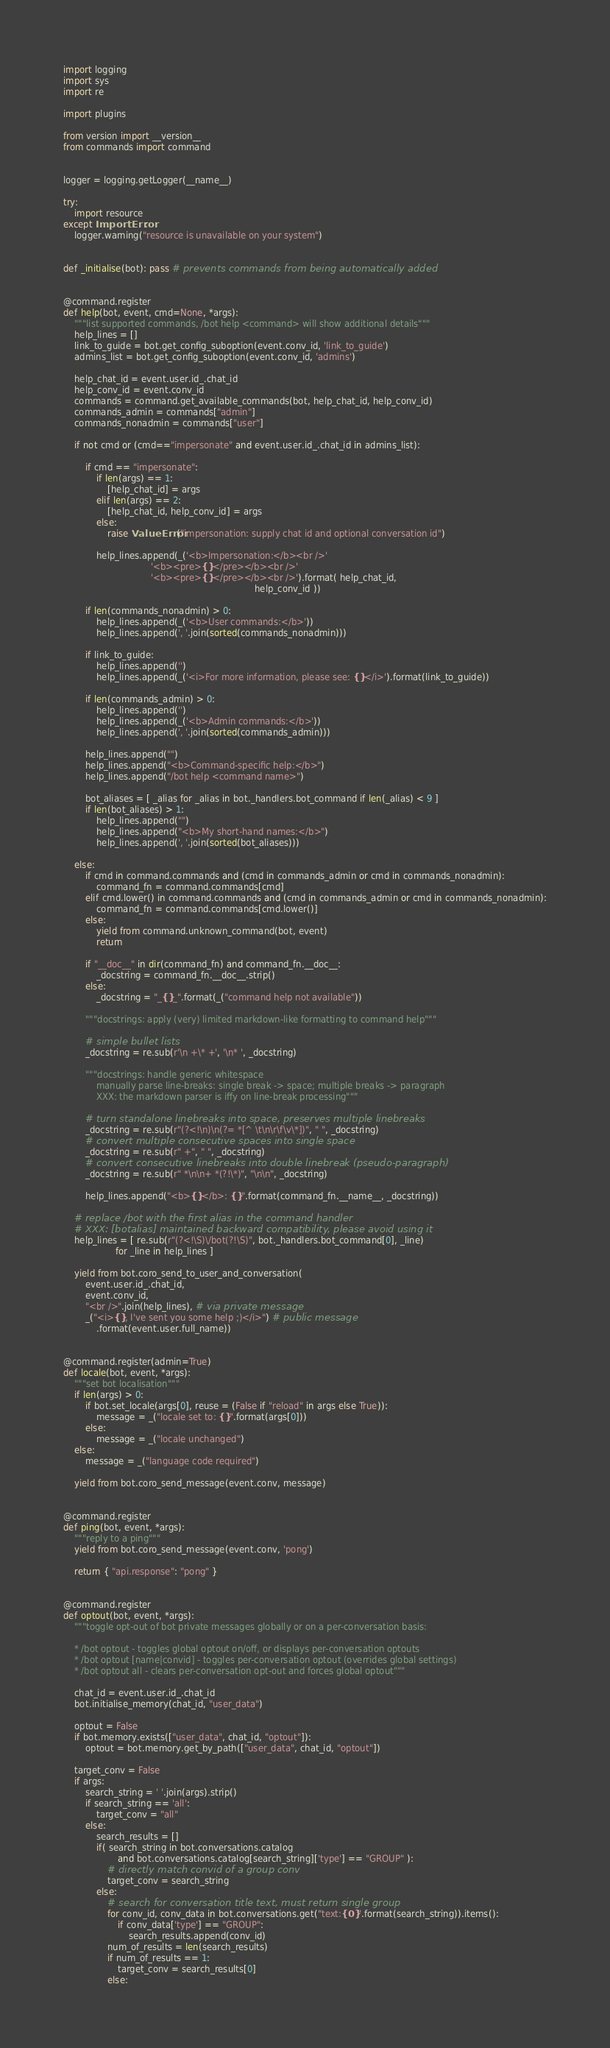Convert code to text. <code><loc_0><loc_0><loc_500><loc_500><_Python_>import logging
import sys
import re

import plugins

from version import __version__
from commands import command


logger = logging.getLogger(__name__)

try:
    import resource
except ImportError:
    logger.warning("resource is unavailable on your system")


def _initialise(bot): pass # prevents commands from being automatically added


@command.register
def help(bot, event, cmd=None, *args):
    """list supported commands, /bot help <command> will show additional details"""
    help_lines = []
    link_to_guide = bot.get_config_suboption(event.conv_id, 'link_to_guide')
    admins_list = bot.get_config_suboption(event.conv_id, 'admins')

    help_chat_id = event.user.id_.chat_id
    help_conv_id = event.conv_id
    commands = command.get_available_commands(bot, help_chat_id, help_conv_id)
    commands_admin = commands["admin"]
    commands_nonadmin = commands["user"]

    if not cmd or (cmd=="impersonate" and event.user.id_.chat_id in admins_list):

        if cmd == "impersonate":
            if len(args) == 1:
                [help_chat_id] = args
            elif len(args) == 2:
                [help_chat_id, help_conv_id] = args
            else:
                raise ValueError("impersonation: supply chat id and optional conversation id")

            help_lines.append(_('<b>Impersonation:</b><br />'
                                '<b><pre>{}</pre></b><br />'
                                '<b><pre>{}</pre></b><br />').format( help_chat_id,
                                                                      help_conv_id ))

        if len(commands_nonadmin) > 0:
            help_lines.append(_('<b>User commands:</b>'))
            help_lines.append(', '.join(sorted(commands_nonadmin)))

        if link_to_guide:
            help_lines.append('')
            help_lines.append(_('<i>For more information, please see: {}</i>').format(link_to_guide))

        if len(commands_admin) > 0:
            help_lines.append('')
            help_lines.append(_('<b>Admin commands:</b>'))
            help_lines.append(', '.join(sorted(commands_admin)))

        help_lines.append("")
        help_lines.append("<b>Command-specific help:</b>")
        help_lines.append("/bot help <command name>")

        bot_aliases = [ _alias for _alias in bot._handlers.bot_command if len(_alias) < 9 ]
        if len(bot_aliases) > 1:
            help_lines.append("")
            help_lines.append("<b>My short-hand names:</b>")
            help_lines.append(', '.join(sorted(bot_aliases)))

    else:
        if cmd in command.commands and (cmd in commands_admin or cmd in commands_nonadmin):
            command_fn = command.commands[cmd]
        elif cmd.lower() in command.commands and (cmd in commands_admin or cmd in commands_nonadmin):
            command_fn = command.commands[cmd.lower()]
        else:
            yield from command.unknown_command(bot, event)
            return

        if "__doc__" in dir(command_fn) and command_fn.__doc__:
            _docstring = command_fn.__doc__.strip()
        else:
            _docstring = "_{}_".format(_("command help not available"))

        """docstrings: apply (very) limited markdown-like formatting to command help"""

        # simple bullet lists
        _docstring = re.sub(r'\n +\* +', '\n* ', _docstring)

        """docstrings: handle generic whitespace
            manually parse line-breaks: single break -> space; multiple breaks -> paragraph
            XXX: the markdown parser is iffy on line-break processing"""

        # turn standalone linebreaks into space, preserves multiple linebreaks
        _docstring = re.sub(r"(?<!\n)\n(?= *[^ \t\n\r\f\v\*])", " ", _docstring)
        # convert multiple consecutive spaces into single space
        _docstring = re.sub(r" +", " ", _docstring)
        # convert consecutive linebreaks into double linebreak (pseudo-paragraph)
        _docstring = re.sub(r" *\n\n+ *(?!\*)", "\n\n", _docstring)

        help_lines.append("<b>{}</b>: {}".format(command_fn.__name__, _docstring))

    # replace /bot with the first alias in the command handler
    # XXX: [botalias] maintained backward compatibility, please avoid using it
    help_lines = [ re.sub(r"(?<!\S)\/bot(?!\S)", bot._handlers.bot_command[0], _line)
                   for _line in help_lines ]

    yield from bot.coro_send_to_user_and_conversation(
        event.user.id_.chat_id,
        event.conv_id,
        "<br />".join(help_lines), # via private message
        _("<i>{}, I've sent you some help ;)</i>") # public message
            .format(event.user.full_name))


@command.register(admin=True)
def locale(bot, event, *args):
    """set bot localisation"""
    if len(args) > 0:
        if bot.set_locale(args[0], reuse = (False if "reload" in args else True)):
            message = _("locale set to: {}".format(args[0]))
        else:
            message = _("locale unchanged")
    else:
        message = _("language code required")

    yield from bot.coro_send_message(event.conv, message)


@command.register
def ping(bot, event, *args):
    """reply to a ping"""
    yield from bot.coro_send_message(event.conv, 'pong')

    return { "api.response": "pong" }


@command.register
def optout(bot, event, *args):
    """toggle opt-out of bot private messages globally or on a per-conversation basis:

    * /bot optout - toggles global optout on/off, or displays per-conversation optouts
    * /bot optout [name|convid] - toggles per-conversation optout (overrides global settings)
    * /bot optout all - clears per-conversation opt-out and forces global optout"""

    chat_id = event.user.id_.chat_id
    bot.initialise_memory(chat_id, "user_data")

    optout = False
    if bot.memory.exists(["user_data", chat_id, "optout"]):
        optout = bot.memory.get_by_path(["user_data", chat_id, "optout"])

    target_conv = False
    if args:
        search_string = ' '.join(args).strip()
        if search_string == 'all':
            target_conv = "all"
        else:
            search_results = []
            if( search_string in bot.conversations.catalog
                    and bot.conversations.catalog[search_string]['type'] == "GROUP" ):
                # directly match convid of a group conv
                target_conv = search_string
            else:
                # search for conversation title text, must return single group
                for conv_id, conv_data in bot.conversations.get("text:{0}".format(search_string)).items():
                    if conv_data['type'] == "GROUP":
                        search_results.append(conv_id)
                num_of_results = len(search_results)
                if num_of_results == 1:
                    target_conv = search_results[0]
                else:</code> 